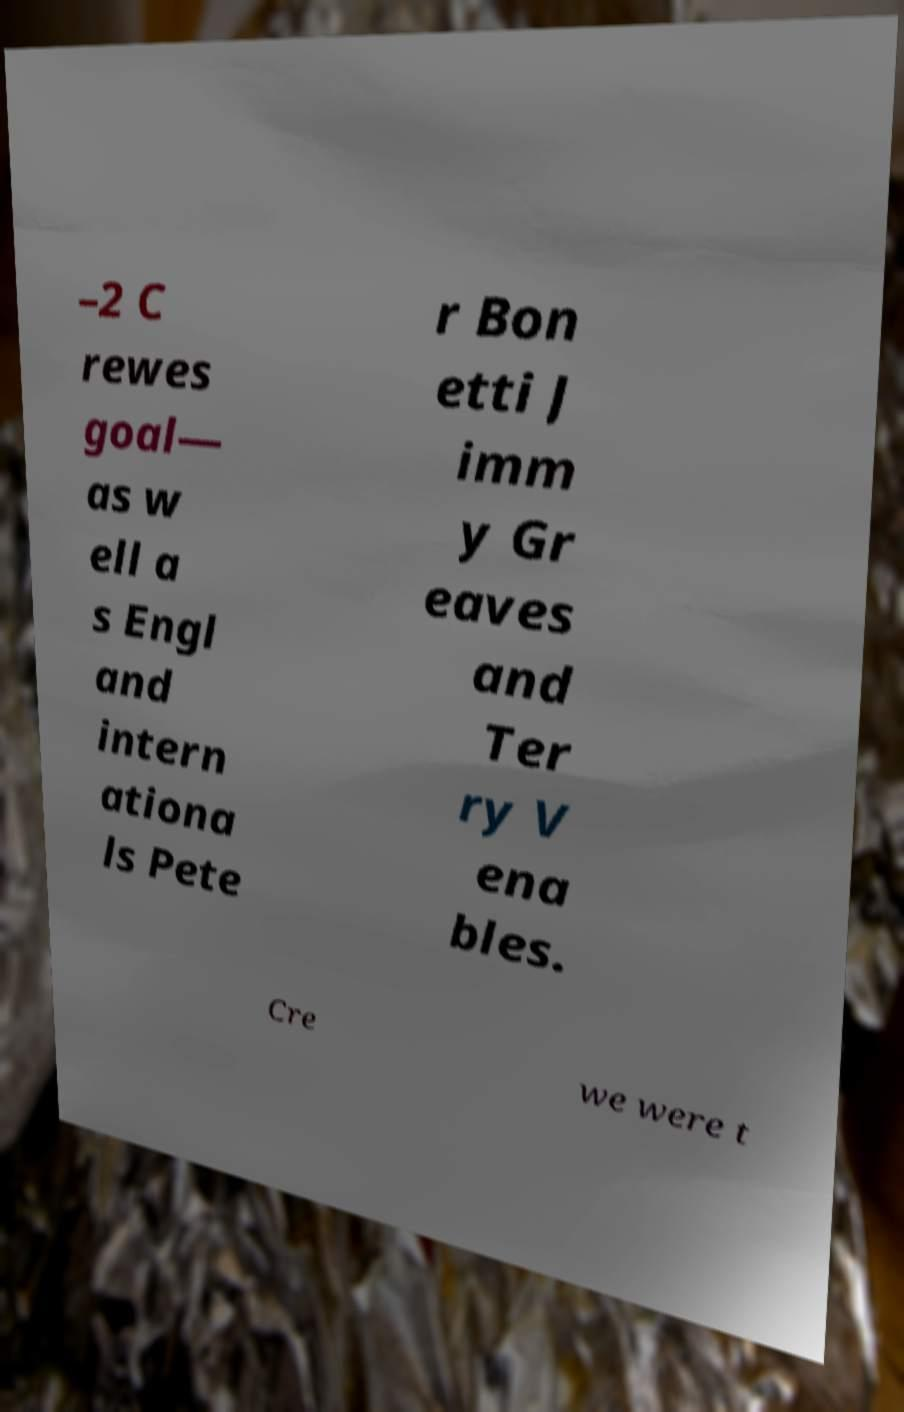Could you assist in decoding the text presented in this image and type it out clearly? –2 C rewes goal— as w ell a s Engl and intern ationa ls Pete r Bon etti J imm y Gr eaves and Ter ry V ena bles. Cre we were t 